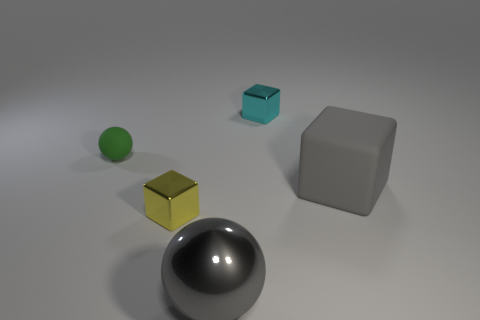What number of metallic blocks have the same color as the small rubber sphere?
Keep it short and to the point. 0. There is a shiny block that is to the right of the big thing in front of the gray block; what is its size?
Ensure brevity in your answer.  Small. What number of objects are either tiny shiny cubes in front of the green rubber sphere or tiny rubber balls?
Keep it short and to the point. 2. Are there any yellow blocks of the same size as the gray metal object?
Your response must be concise. No. Is there a tiny green object in front of the ball behind the rubber cube?
Provide a short and direct response. No. How many cubes are brown rubber objects or tiny objects?
Make the answer very short. 2. Are there any other yellow things of the same shape as the yellow metal object?
Offer a very short reply. No. The small matte object has what shape?
Offer a very short reply. Sphere. What number of things are green matte spheres or shiny balls?
Offer a very short reply. 2. Does the shiny block to the left of the shiny ball have the same size as the cyan block on the right side of the small yellow thing?
Keep it short and to the point. Yes. 